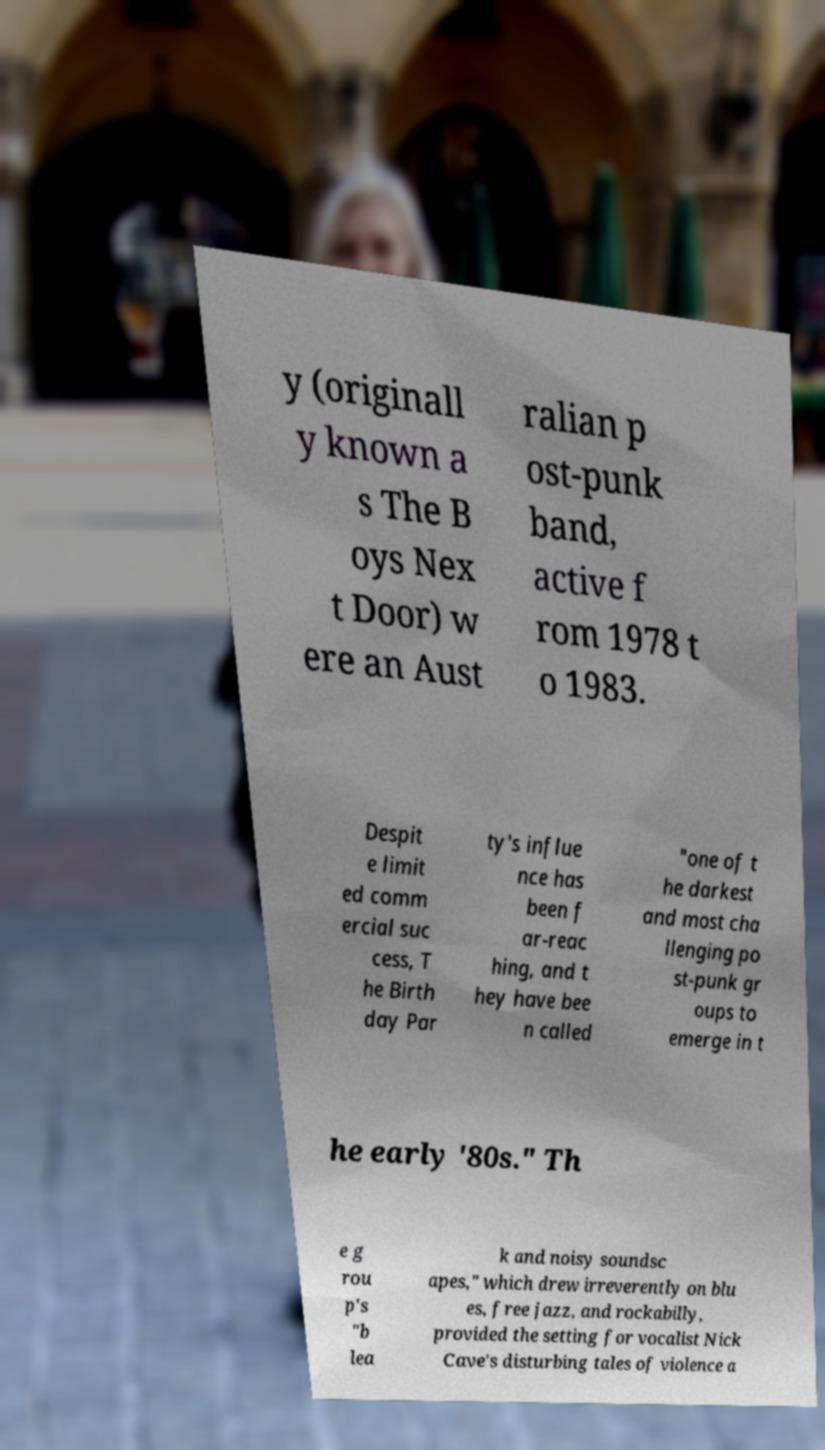Could you extract and type out the text from this image? y (originall y known a s The B oys Nex t Door) w ere an Aust ralian p ost-punk band, active f rom 1978 t o 1983. Despit e limit ed comm ercial suc cess, T he Birth day Par ty's influe nce has been f ar-reac hing, and t hey have bee n called "one of t he darkest and most cha llenging po st-punk gr oups to emerge in t he early '80s." Th e g rou p's "b lea k and noisy soundsc apes," which drew irreverently on blu es, free jazz, and rockabilly, provided the setting for vocalist Nick Cave's disturbing tales of violence a 